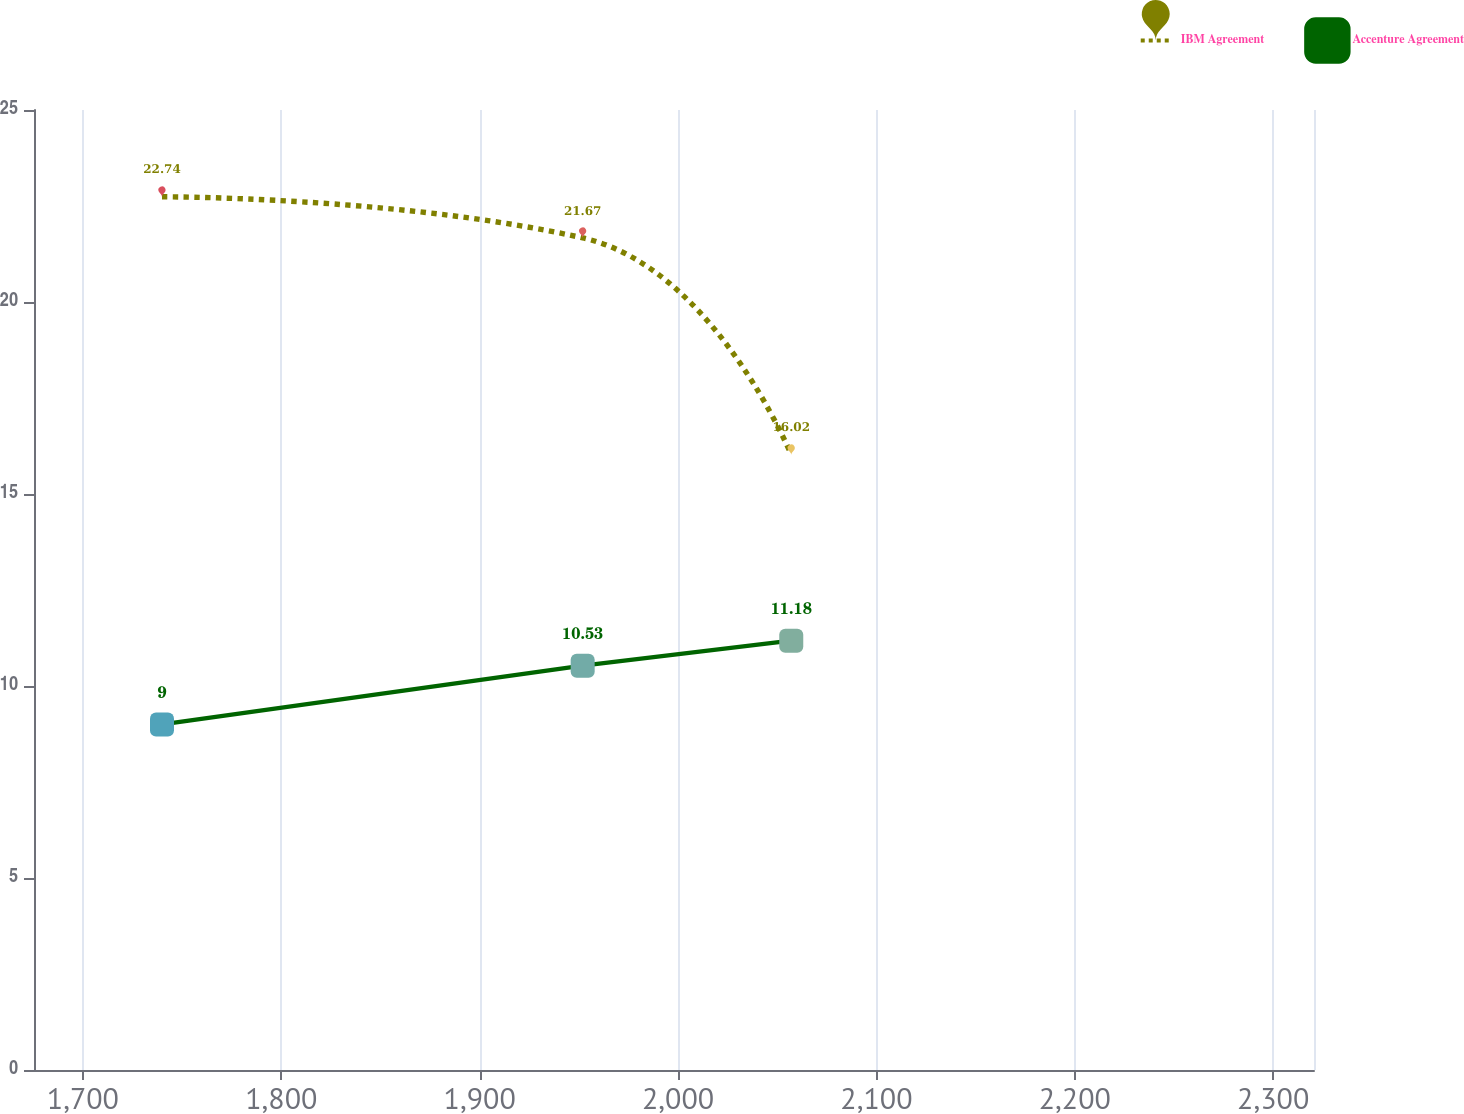Convert chart to OTSL. <chart><loc_0><loc_0><loc_500><loc_500><line_chart><ecel><fcel>IBM Agreement<fcel>Accenture Agreement<nl><fcel>1739.88<fcel>22.74<fcel>9<nl><fcel>1951.93<fcel>21.67<fcel>10.53<nl><fcel>2057.07<fcel>16.02<fcel>11.18<nl><fcel>2385.09<fcel>18.16<fcel>10.31<nl></chart> 